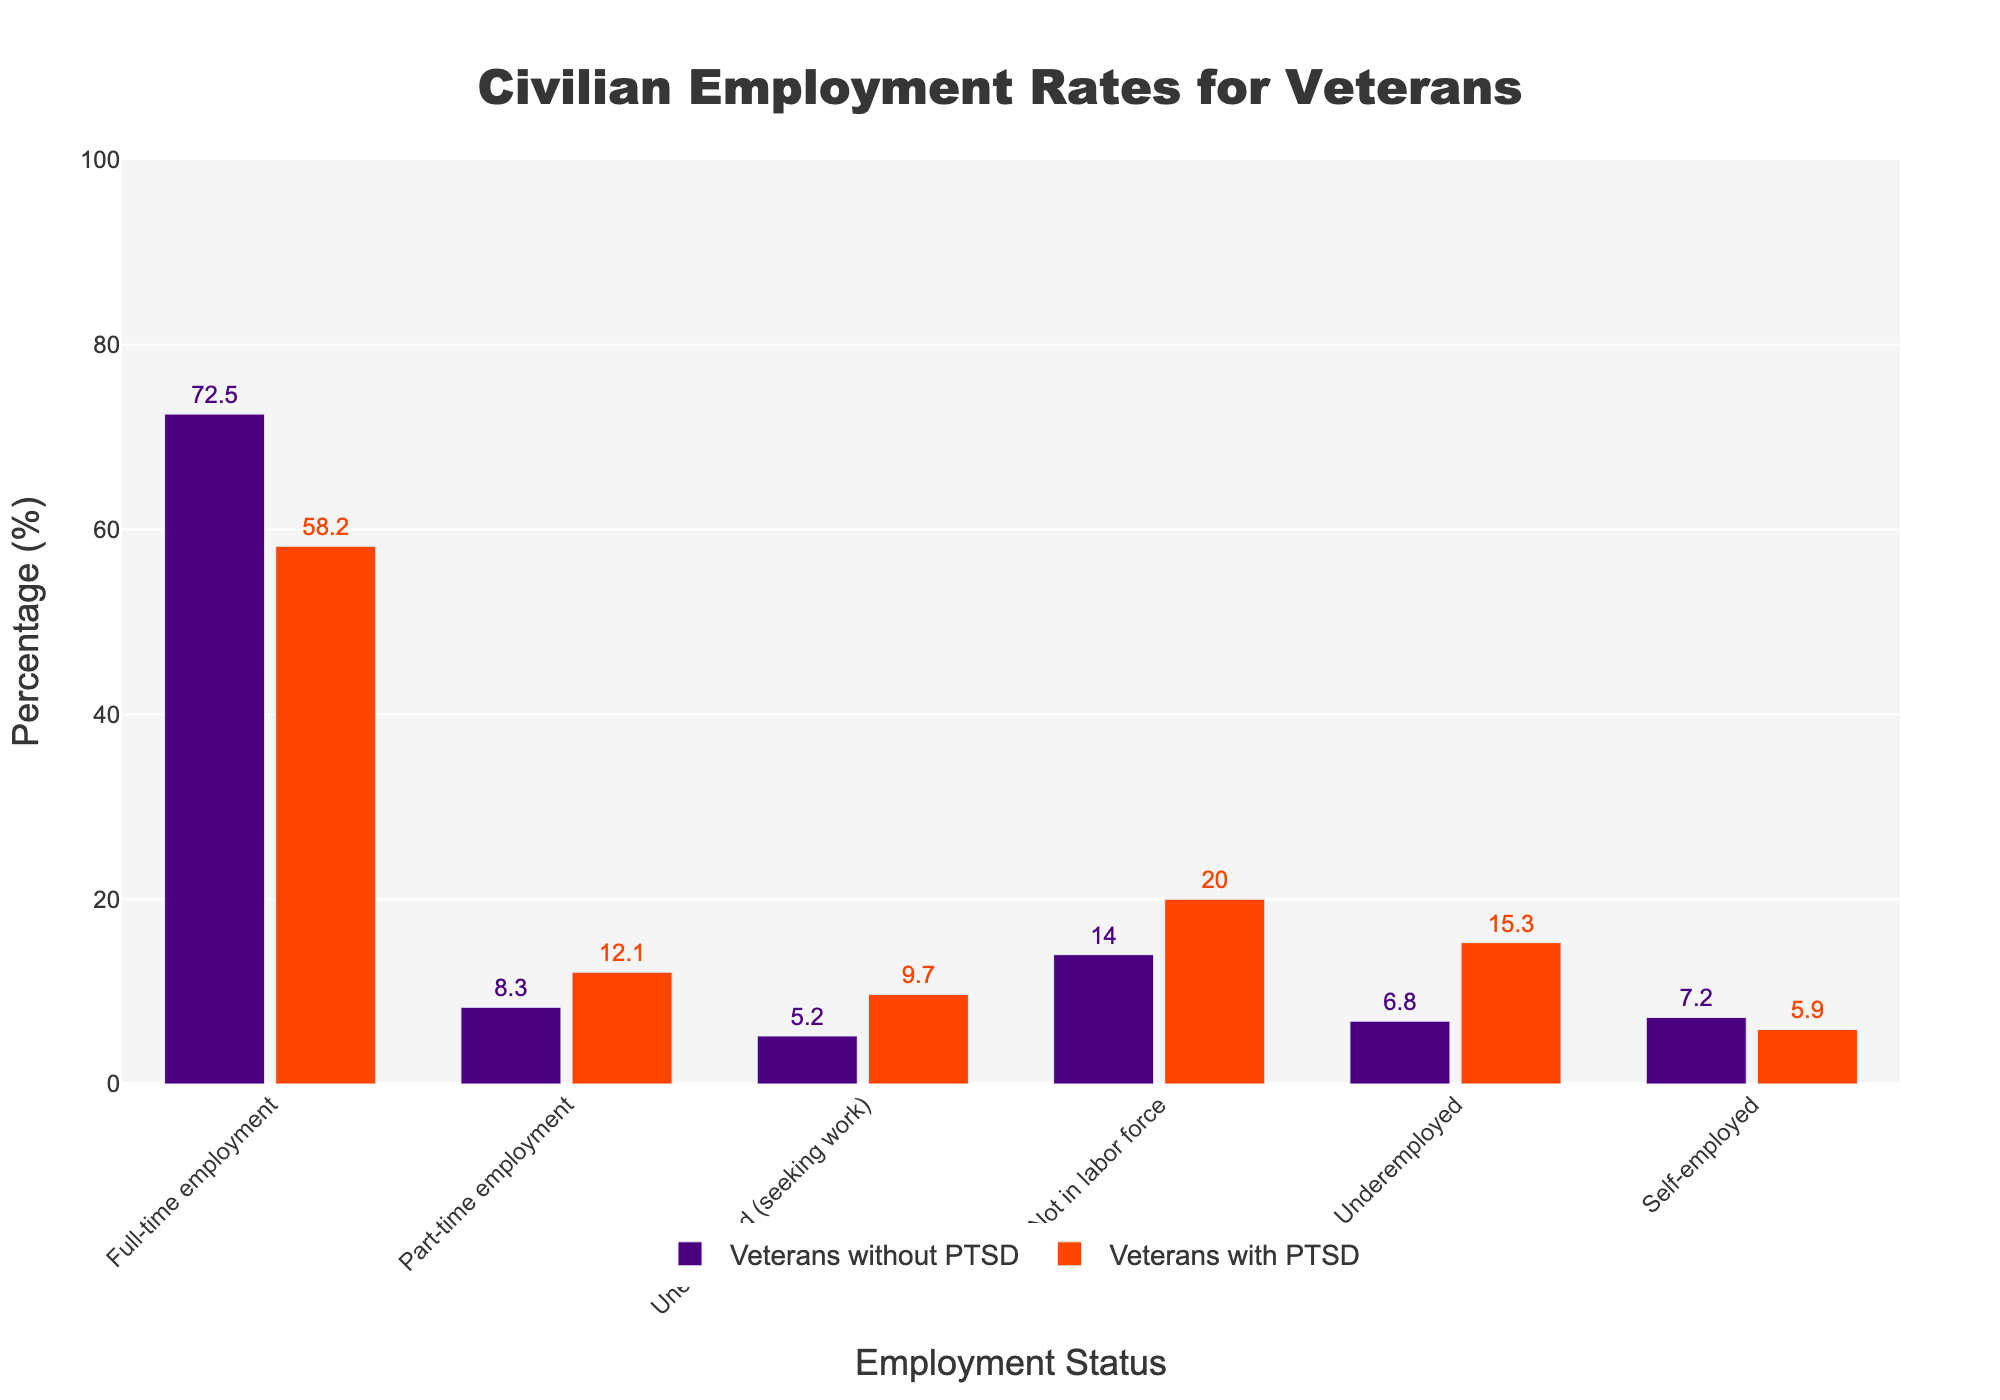what is the difference in full-time employment rates between veterans without PTSD and those with PTSD? Veterans without PTSD have a full-time employment rate of 72.5%, and veterans with PTSD have a rate of 58.2%. The difference is calculated as 72.5% - 58.2%.
Answer: 14.3% which employment category shows the highest percentage of full-time employment? By observing the bar chart, full-time employment has the highest value for both groups. For veterans without PTSD, it is 72.5%, and for veterans with PTSD, it is 58.2%.
Answer: Full-time employment comparing unemployed (seeking work) rates, which group has a higher percentage? By comparing the height of the bars for unemployed (seeking work), veterans with PTSD have a higher percentage (9.7%) than veterans without PTSD (5.2%).
Answer: Veterans with PTSD which category shows a greater disparity between veterans with and without PTSD, in terms of percentage differences? Calculate the absolute differences for each category. Full-time: 14.3%, Part-time: 3.8%, Unemployed: 4.5%, Not in labor force: 6.0%, Underemployed: 8.5%, Self-employed: 1.3%. The greatest disparity is in Underemployed (8.5%).
Answer: Underemployed what is the combined percentage for veterans with PTSD who are unemployed (seeking work) and part-time employed? Add the percentages of unemployed (seeking work) (9.7%) and part-time employment (12.1%) for veterans with PTSD. 9.7% + 12.1% = 21.8%.
Answer: 21.8% how much higher is the rate of underemployment among veterans with PTSD compared to veterans without PTSD? The underemployment rate among veterans with PTSD is 15.3%, and for those without PTSD, it is 6.8%. The difference is 15.3% - 6.8%.
Answer: 8.5% which employment category has nearly equal percentages for veterans with and without PTSD? By comparing the bar heights and percentages, self-employment has 7.2% for veterans without PTSD and 5.9% for veterans with PTSD, showing the least variation.
Answer: Self-employment what's the total percentage of veterans without PTSD in part-time, self-employed, and underemployed categories? Add the percentages: part-time employment (8.3%), self-employed (7.2%), and underemployed (6.8%). 8.3% + 7.2% + 6.8% = 22.3%.
Answer: 22.3% 